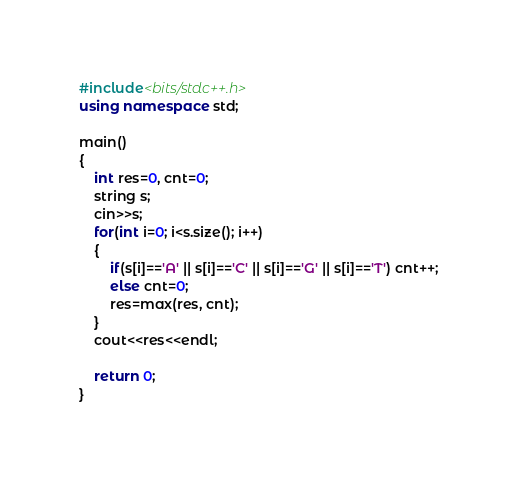Convert code to text. <code><loc_0><loc_0><loc_500><loc_500><_C++_>#include<bits/stdc++.h>
using namespace std;

main()
{
    int res=0, cnt=0;
    string s;
    cin>>s;
    for(int i=0; i<s.size(); i++)
    {
        if(s[i]=='A' || s[i]=='C' || s[i]=='G' || s[i]=='T') cnt++;
        else cnt=0;
        res=max(res, cnt);
    }
    cout<<res<<endl;

    return 0;
}
</code> 